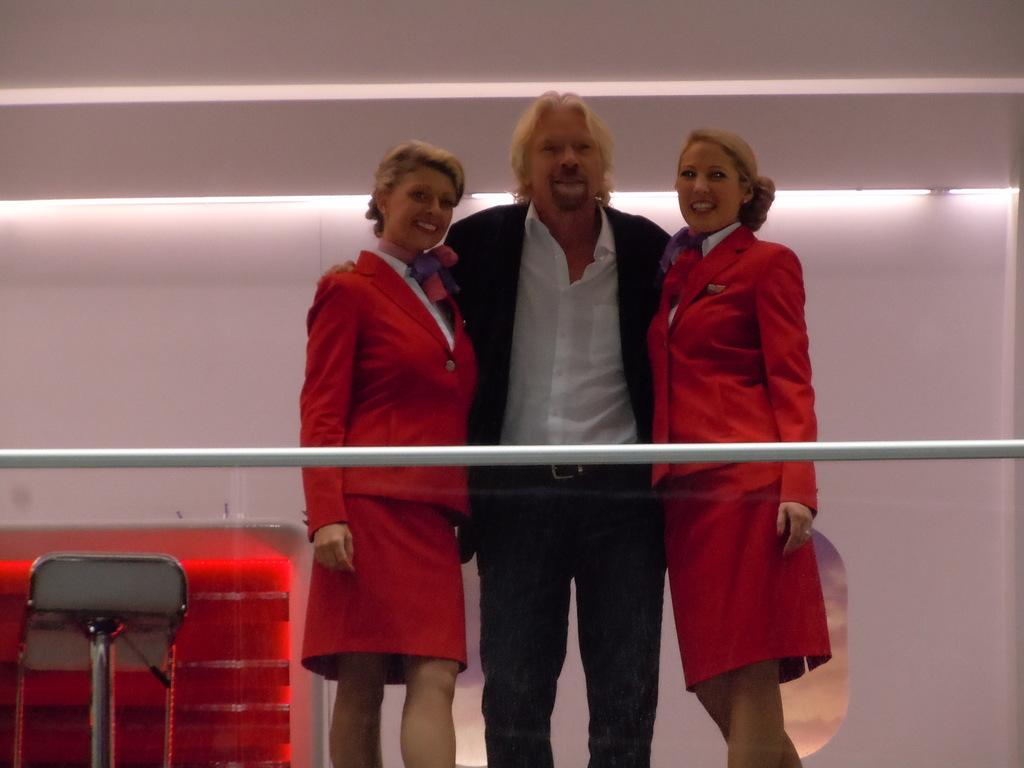How many people are in the image? There are three people standing in the center of the image. What is located in the foreground of the image? There is railing in the foreground of the image. What object can be seen on the left side of the image? There is a chair on the left side of the image. What can be seen in the background of the image? There are lights and a wall visible in the background of the image. What type of honey is being used to make the noise in the image? There is no honey or noise present in the image. Can you see any bats flying around in the image? There are no bats visible in the image. 